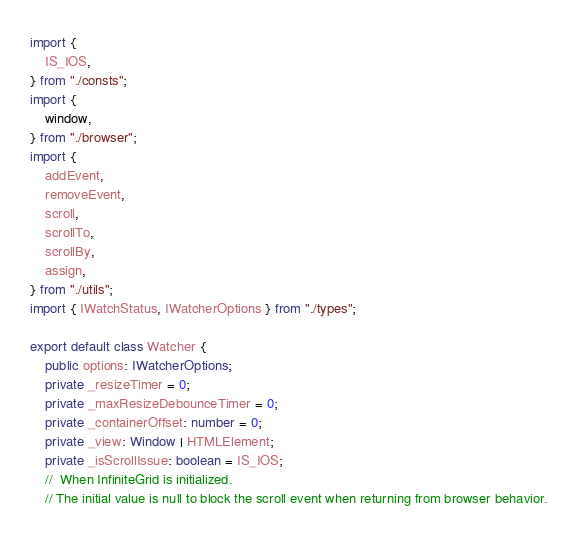<code> <loc_0><loc_0><loc_500><loc_500><_TypeScript_>import {
	IS_IOS,
} from "./consts";
import {
	window,
} from "./browser";
import {
	addEvent,
	removeEvent,
	scroll,
	scrollTo,
	scrollBy,
	assign,
} from "./utils";
import { IWatchStatus, IWatcherOptions } from "./types";

export default class Watcher {
	public options: IWatcherOptions;
	private _resizeTimer = 0;
	private _maxResizeDebounceTimer = 0;
	private _containerOffset: number = 0;
	private _view: Window | HTMLElement;
	private _isScrollIssue: boolean = IS_IOS;
	//  When InfiniteGrid is initialized.
	// The initial value is null to block the scroll event when returning from browser behavior.</code> 